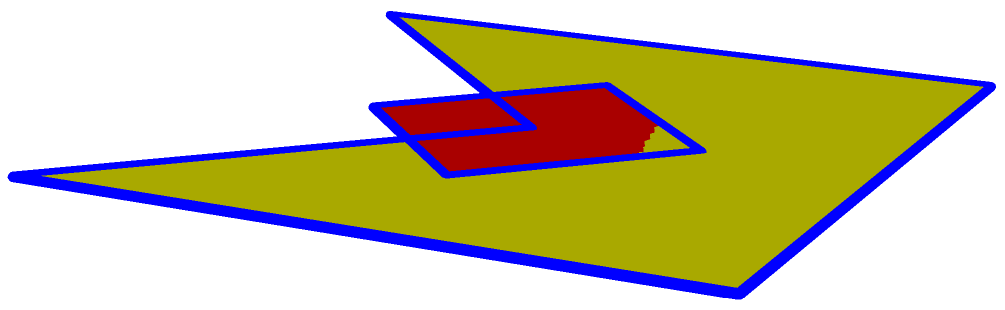The Pittsburgh Steelers' logo has been transformed into a 3D polyhedron, as shown in the diagram. Determine the Euler characteristic of this shape, given that it has 9 vertices, 13 edges, and 5 faces. To find the Euler characteristic of the polyhedron, we'll follow these steps:

1. Recall the Euler's formula for polyhedra:
   $$V - E + F = \chi$$
   Where:
   $V$ = number of vertices
   $E$ = number of edges
   $F$ = number of faces
   $\chi$ = Euler characteristic

2. We are given:
   $V = 9$ (vertices)
   $E = 13$ (edges)
   $F = 5$ (faces)

3. Let's substitute these values into Euler's formula:
   $$\chi = V - E + F$$
   $$\chi = 9 - 13 + 5$$

4. Simplify:
   $$\chi = -4 + 5 = 1$$

Therefore, the Euler characteristic of the Steelers logo polyhedron is 1.
Answer: 1 